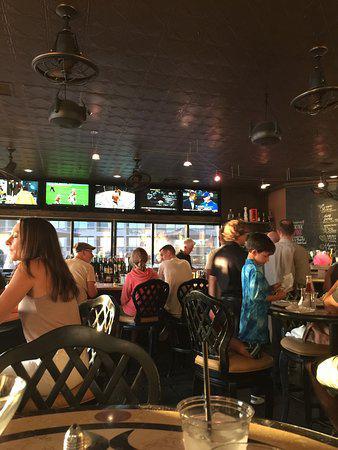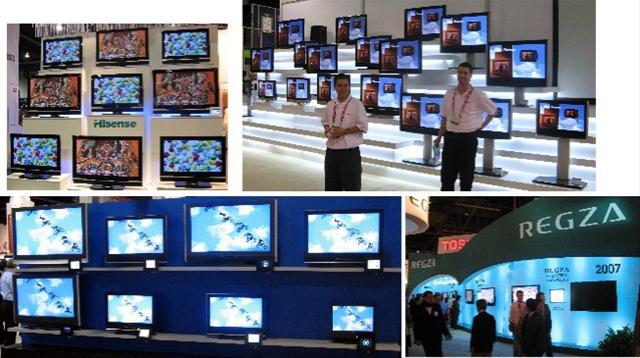The first image is the image on the left, the second image is the image on the right. Assess this claim about the two images: "Left image shows people in a bar with a row of screens overhead.". Correct or not? Answer yes or no. Yes. The first image is the image on the left, the second image is the image on the right. For the images displayed, is the sentence "People are hanging around in a barlike atmosphere in one of the images." factually correct? Answer yes or no. Yes. 